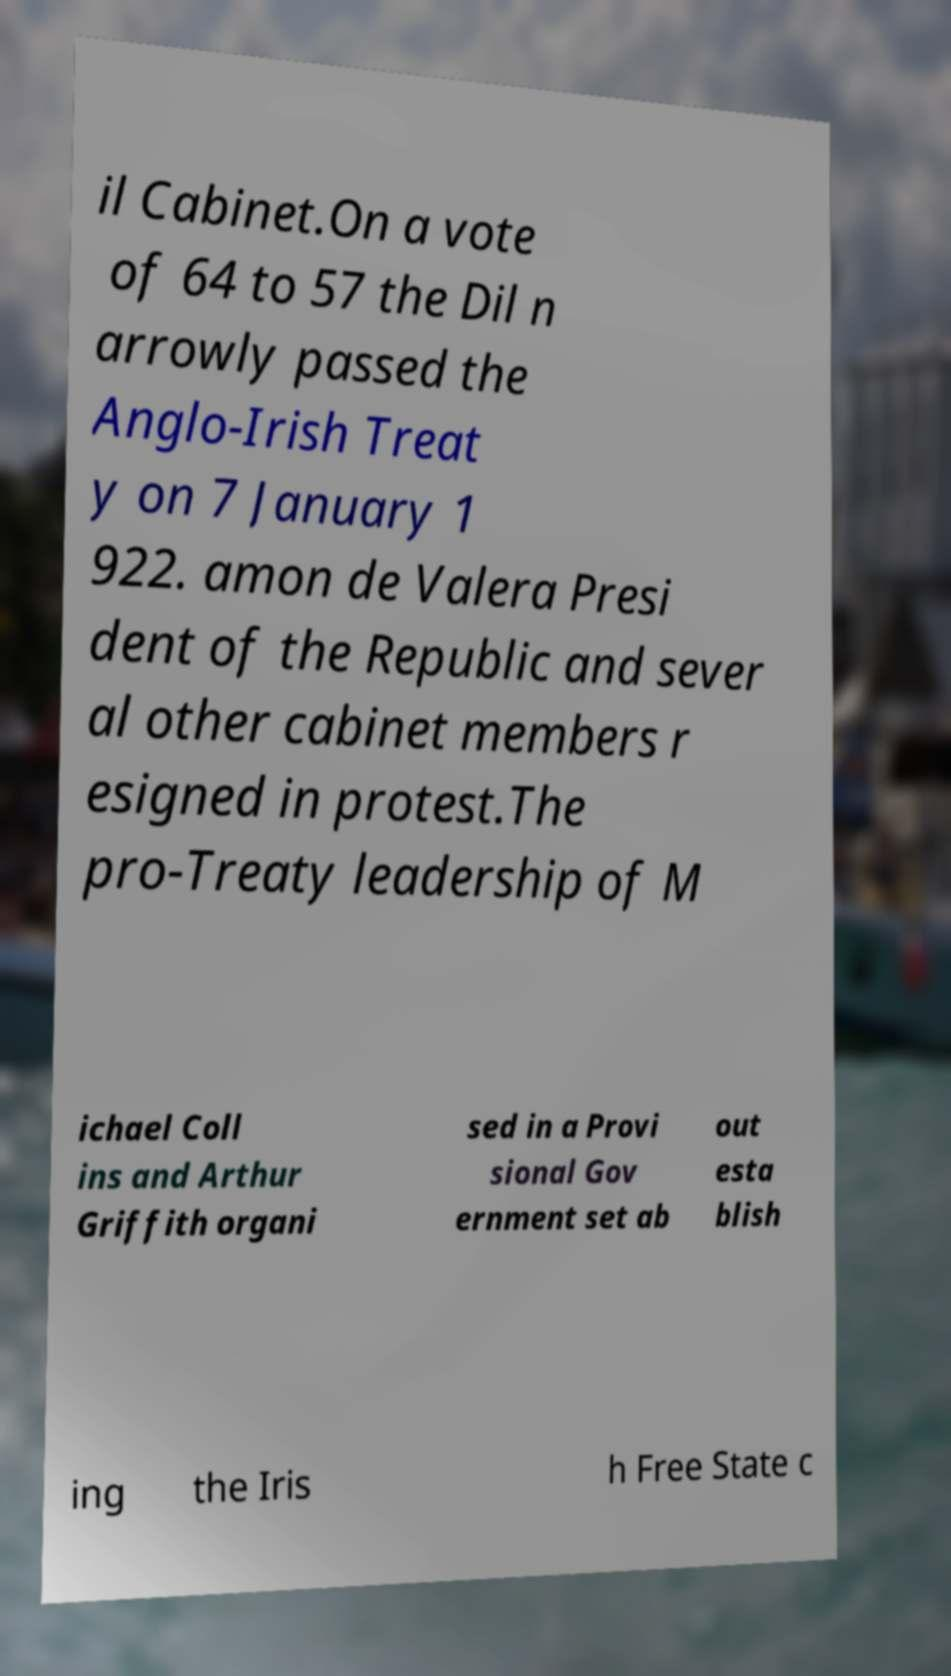Could you assist in decoding the text presented in this image and type it out clearly? il Cabinet.On a vote of 64 to 57 the Dil n arrowly passed the Anglo-Irish Treat y on 7 January 1 922. amon de Valera Presi dent of the Republic and sever al other cabinet members r esigned in protest.The pro-Treaty leadership of M ichael Coll ins and Arthur Griffith organi sed in a Provi sional Gov ernment set ab out esta blish ing the Iris h Free State c 